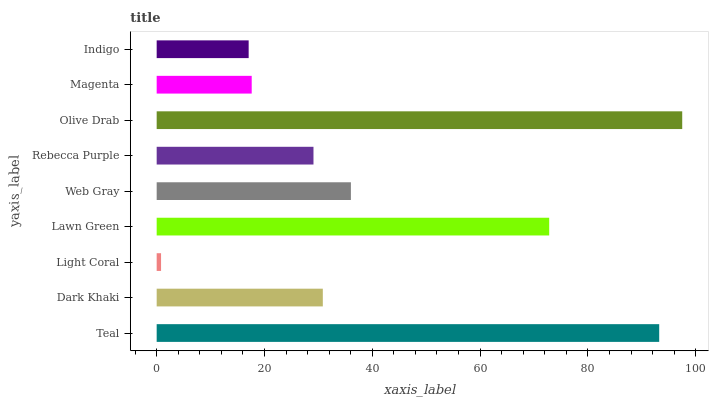Is Light Coral the minimum?
Answer yes or no. Yes. Is Olive Drab the maximum?
Answer yes or no. Yes. Is Dark Khaki the minimum?
Answer yes or no. No. Is Dark Khaki the maximum?
Answer yes or no. No. Is Teal greater than Dark Khaki?
Answer yes or no. Yes. Is Dark Khaki less than Teal?
Answer yes or no. Yes. Is Dark Khaki greater than Teal?
Answer yes or no. No. Is Teal less than Dark Khaki?
Answer yes or no. No. Is Dark Khaki the high median?
Answer yes or no. Yes. Is Dark Khaki the low median?
Answer yes or no. Yes. Is Web Gray the high median?
Answer yes or no. No. Is Light Coral the low median?
Answer yes or no. No. 